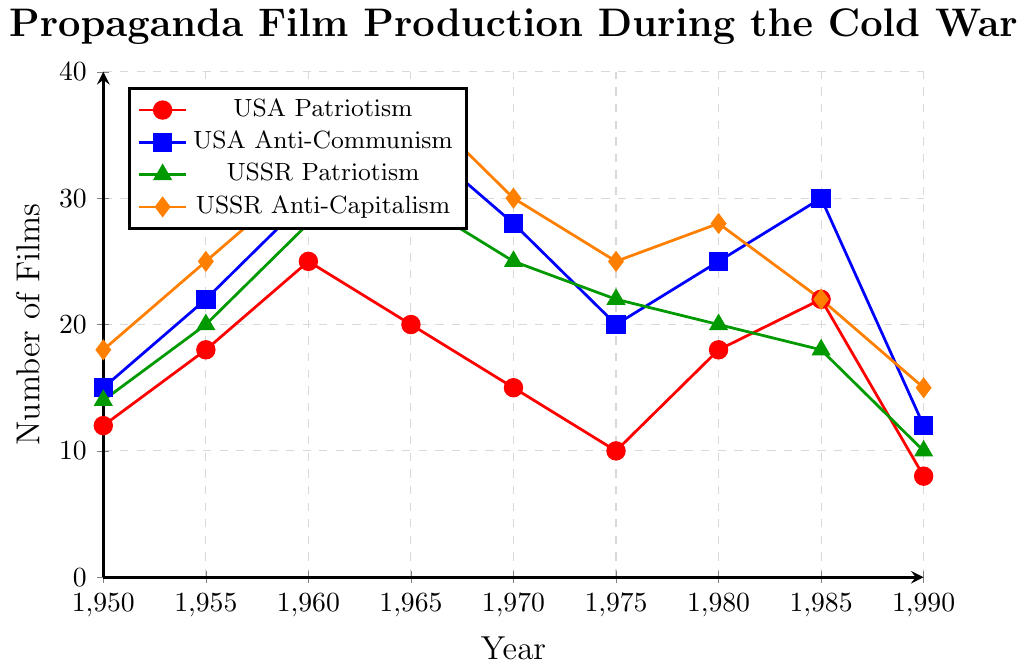What year did both the USA and USSR have the highest production of propaganda films in any category? Refer to the highest points in any line for both USA and USSR categories. The USA's highest production is in 1965 for Anti-Communism (35 films), and the USSR's highest production is in 1965 for Anti-Capitalism (38 films).
Answer: 1965 In which year did the production of USA Patriotism films experience the largest increase from the previous year? Calculate the differences between consecutive years for USA Patriotism films: 6 (1955-1950), 7 (1960-1955), -5 (1965-1960), -5 (1970-1965), -5 (1975-1970), 8 (1980-1975), 4 (1985-1980), -14 (1990-1985). The largest increase is from 1975 to 1980, which is 8 films.
Answer: 1980 Between 1960 and 1975, did the number of USSR Anti-Capitalism films consistently decrease? Observe the trend in the USSR Anti-Capitalism line from 1960 to 1975. The production decreases from 38 in 1965 to 30 in 1970 and 25 in 1975.
Answer: Yes What is the average number of USA Anti-Communism films produced in the 1980s? Refer to data points for USA Anti-Communism in 1980 and 1985, then calculate the average: (25 + 30) / 2 = 27.5.
Answer: 27.5 Which category saw a higher production in 1990, USA Patriotism or USSR Anti-Capitalism? Compare the data points for these categories in 1990. USA Patriotism had 8 films while USSR Anti-Capitalism had 15 films.
Answer: USSR Anti-Capitalism What was the total production of films in the USSR Patriotism category in the 1970s? Sum the data points for USSR Patriotism from 1970, 1975, and 1980: 25 + 22 + 20 = 67.
Answer: 67 Which year had the smallest difference between the USA's production of Patriotism and Anti-Communism films? Calculate the absolute differences for each year: 3 (1950), 4 (1955), 5 (1960), 15 (1965), 13 (1970), 10 (1975), 7 (1980), 8 (1985), 4 (1990). The smallest difference is 3 in 1950.
Answer: 1950 What is the overall trend of the USSR Patriotism films from 1950 to 1990? Observe the data points and identify the trend: Increase from 1950 (14) to 1965 (30), followed by a steady decline to 1990 (10).
Answer: Increase then decrease How many more USSR Anti-Capitalism films were produced compared to USA Patriotism films in 1965? Subtract the number of USA Patriotism films from USSR Anti-Capitalism films in 1965: 38 - 20 = 18.
Answer: 18 